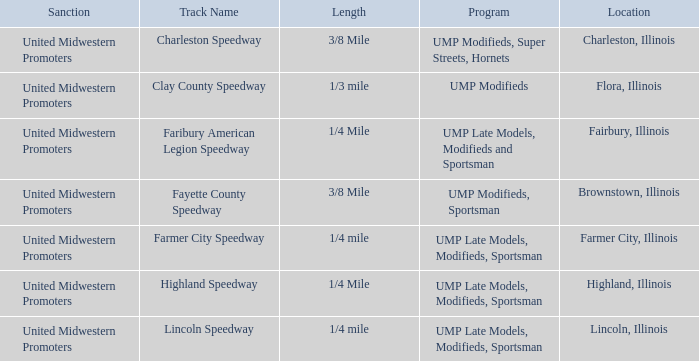What location is farmer city speedway? Farmer City, Illinois. 